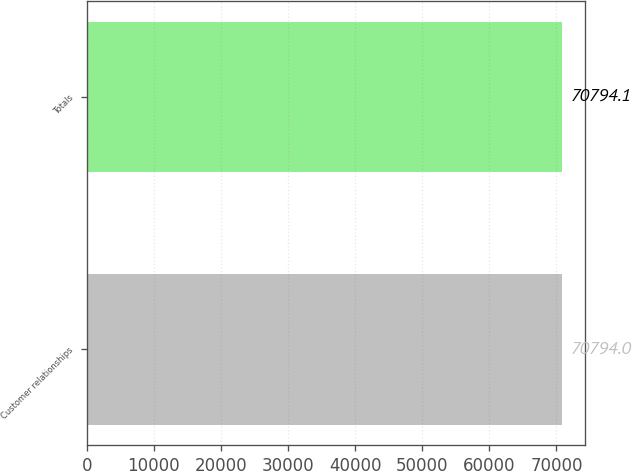Convert chart to OTSL. <chart><loc_0><loc_0><loc_500><loc_500><bar_chart><fcel>Customer relationships<fcel>Totals<nl><fcel>70794<fcel>70794.1<nl></chart> 